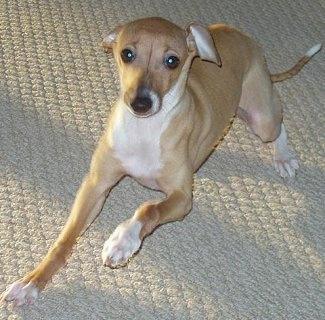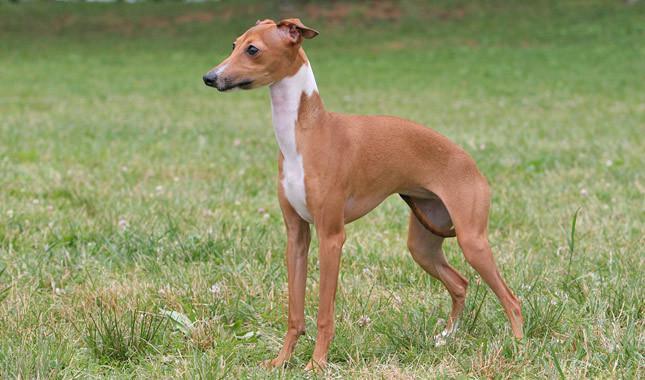The first image is the image on the left, the second image is the image on the right. Assess this claim about the two images: "Left image shows a hound standing on a hard surface.". Correct or not? Answer yes or no. No. The first image is the image on the left, the second image is the image on the right. Considering the images on both sides, is "A dog is standing on all four legs with it's full body visible." valid? Answer yes or no. Yes. 